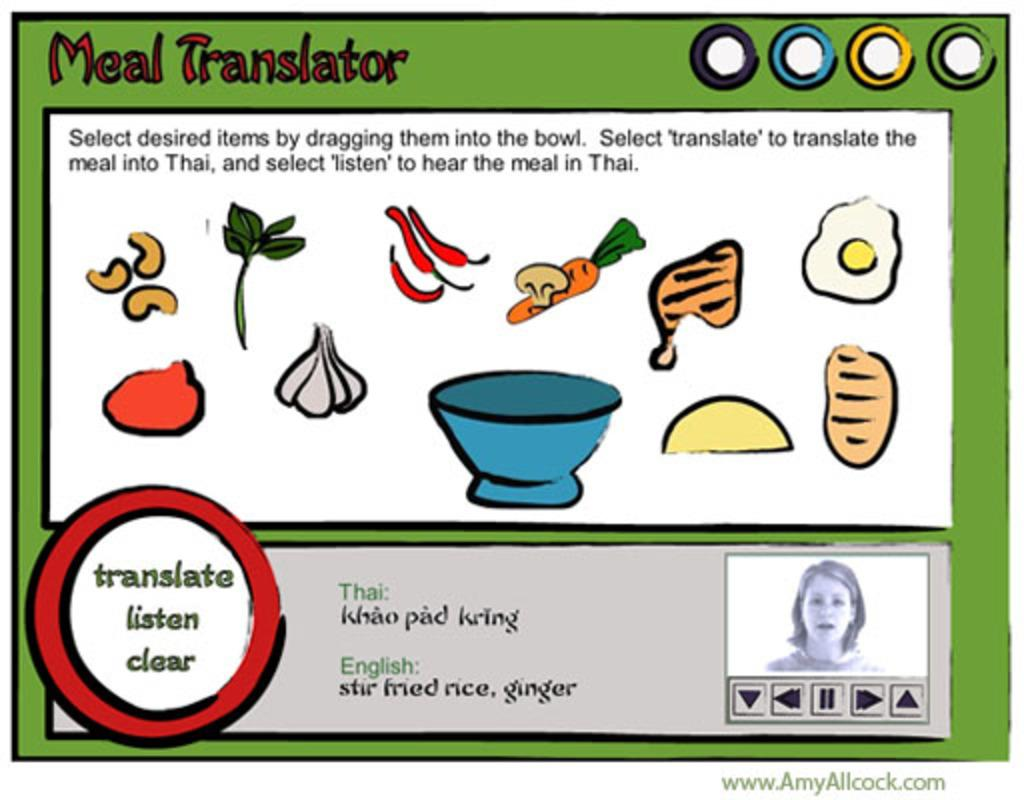What type of image is being described? The image is an edited graphic. Are there any words or phrases written on the image? Yes, there is there is text written on the image. How many wrens can be seen in the image? There are no wrens present in the image, as it is an edited graphic with text and does not depict any animals. 